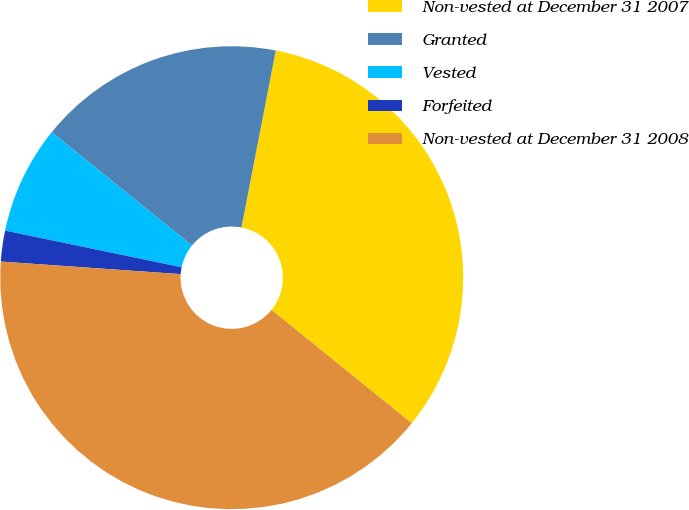Convert chart. <chart><loc_0><loc_0><loc_500><loc_500><pie_chart><fcel>Non-vested at December 31 2007<fcel>Granted<fcel>Vested<fcel>Forfeited<fcel>Non-vested at December 31 2008<nl><fcel>32.77%<fcel>17.23%<fcel>7.56%<fcel>2.15%<fcel>40.3%<nl></chart> 